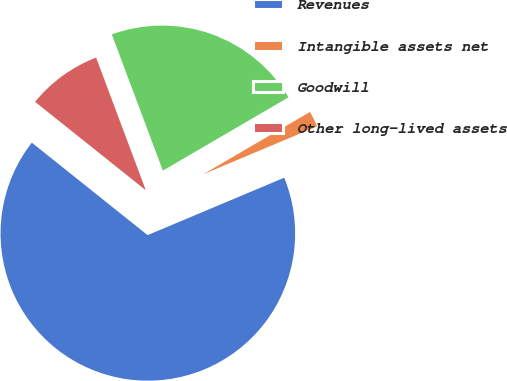Convert chart. <chart><loc_0><loc_0><loc_500><loc_500><pie_chart><fcel>Revenues<fcel>Intangible assets net<fcel>Goodwill<fcel>Other long-lived assets<nl><fcel>67.06%<fcel>2.07%<fcel>22.3%<fcel>8.57%<nl></chart> 